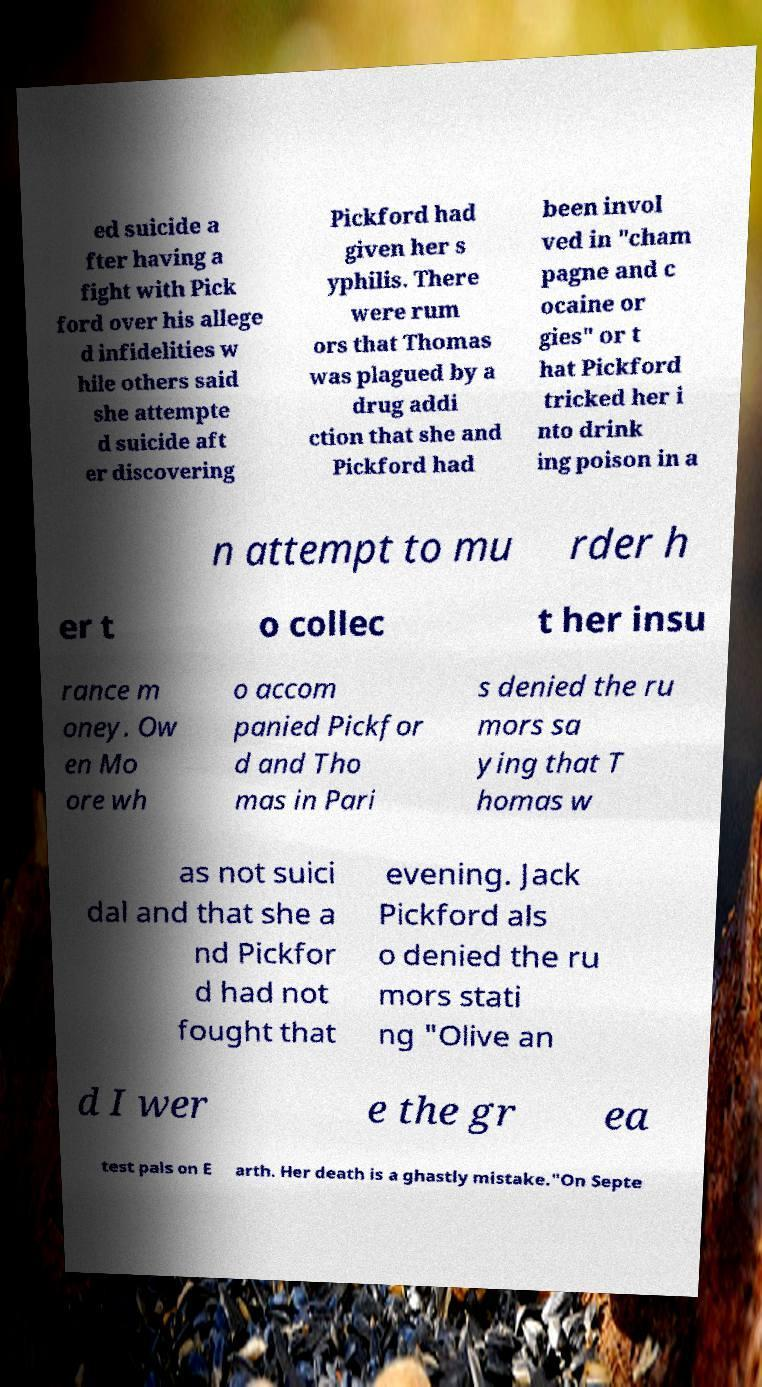Can you accurately transcribe the text from the provided image for me? ed suicide a fter having a fight with Pick ford over his allege d infidelities w hile others said she attempte d suicide aft er discovering Pickford had given her s yphilis. There were rum ors that Thomas was plagued by a drug addi ction that she and Pickford had been invol ved in "cham pagne and c ocaine or gies" or t hat Pickford tricked her i nto drink ing poison in a n attempt to mu rder h er t o collec t her insu rance m oney. Ow en Mo ore wh o accom panied Pickfor d and Tho mas in Pari s denied the ru mors sa ying that T homas w as not suici dal and that she a nd Pickfor d had not fought that evening. Jack Pickford als o denied the ru mors stati ng "Olive an d I wer e the gr ea test pals on E arth. Her death is a ghastly mistake."On Septe 